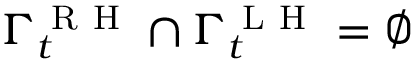<formula> <loc_0><loc_0><loc_500><loc_500>\Gamma _ { t } ^ { R H } \cap \Gamma _ { t } ^ { L H } = \varnothing</formula> 